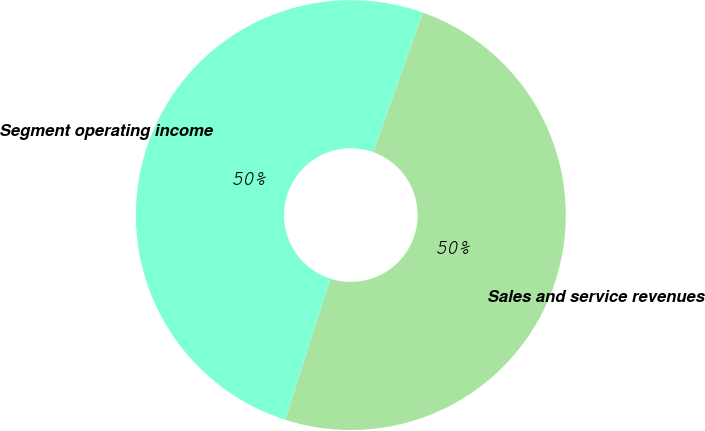Convert chart. <chart><loc_0><loc_0><loc_500><loc_500><pie_chart><fcel>Sales and service revenues<fcel>Segment operating income<nl><fcel>49.5%<fcel>50.5%<nl></chart> 